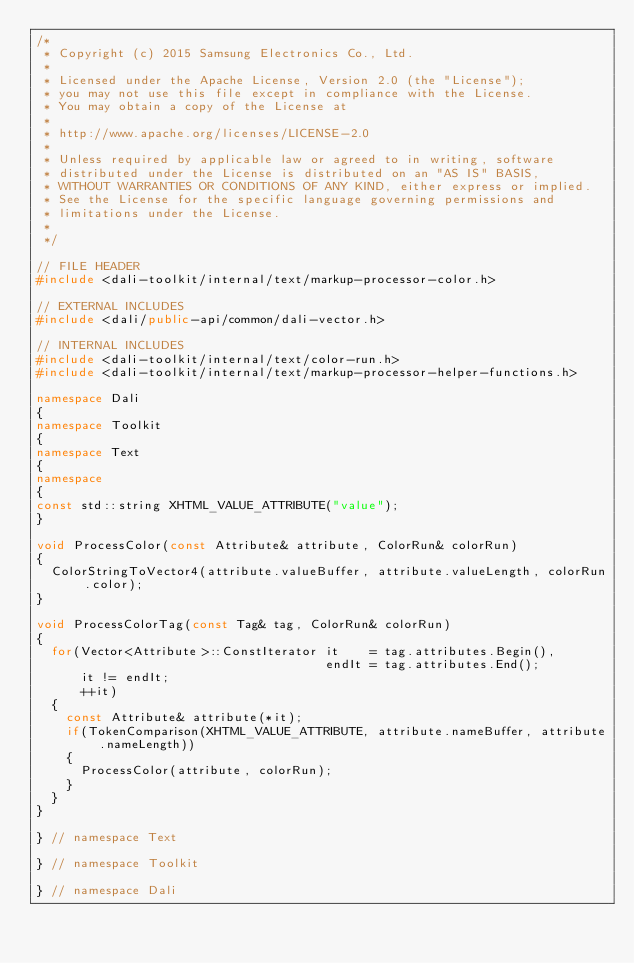<code> <loc_0><loc_0><loc_500><loc_500><_C++_>/*
 * Copyright (c) 2015 Samsung Electronics Co., Ltd.
 *
 * Licensed under the Apache License, Version 2.0 (the "License");
 * you may not use this file except in compliance with the License.
 * You may obtain a copy of the License at
 *
 * http://www.apache.org/licenses/LICENSE-2.0
 *
 * Unless required by applicable law or agreed to in writing, software
 * distributed under the License is distributed on an "AS IS" BASIS,
 * WITHOUT WARRANTIES OR CONDITIONS OF ANY KIND, either express or implied.
 * See the License for the specific language governing permissions and
 * limitations under the License.
 *
 */

// FILE HEADER
#include <dali-toolkit/internal/text/markup-processor-color.h>

// EXTERNAL INCLUDES
#include <dali/public-api/common/dali-vector.h>

// INTERNAL INCLUDES
#include <dali-toolkit/internal/text/color-run.h>
#include <dali-toolkit/internal/text/markup-processor-helper-functions.h>

namespace Dali
{
namespace Toolkit
{
namespace Text
{
namespace
{
const std::string XHTML_VALUE_ATTRIBUTE("value");
}

void ProcessColor(const Attribute& attribute, ColorRun& colorRun)
{
  ColorStringToVector4(attribute.valueBuffer, attribute.valueLength, colorRun.color);
}

void ProcessColorTag(const Tag& tag, ColorRun& colorRun)
{
  for(Vector<Attribute>::ConstIterator it    = tag.attributes.Begin(),
                                       endIt = tag.attributes.End();
      it != endIt;
      ++it)
  {
    const Attribute& attribute(*it);
    if(TokenComparison(XHTML_VALUE_ATTRIBUTE, attribute.nameBuffer, attribute.nameLength))
    {
      ProcessColor(attribute, colorRun);
    }
  }
}

} // namespace Text

} // namespace Toolkit

} // namespace Dali
</code> 